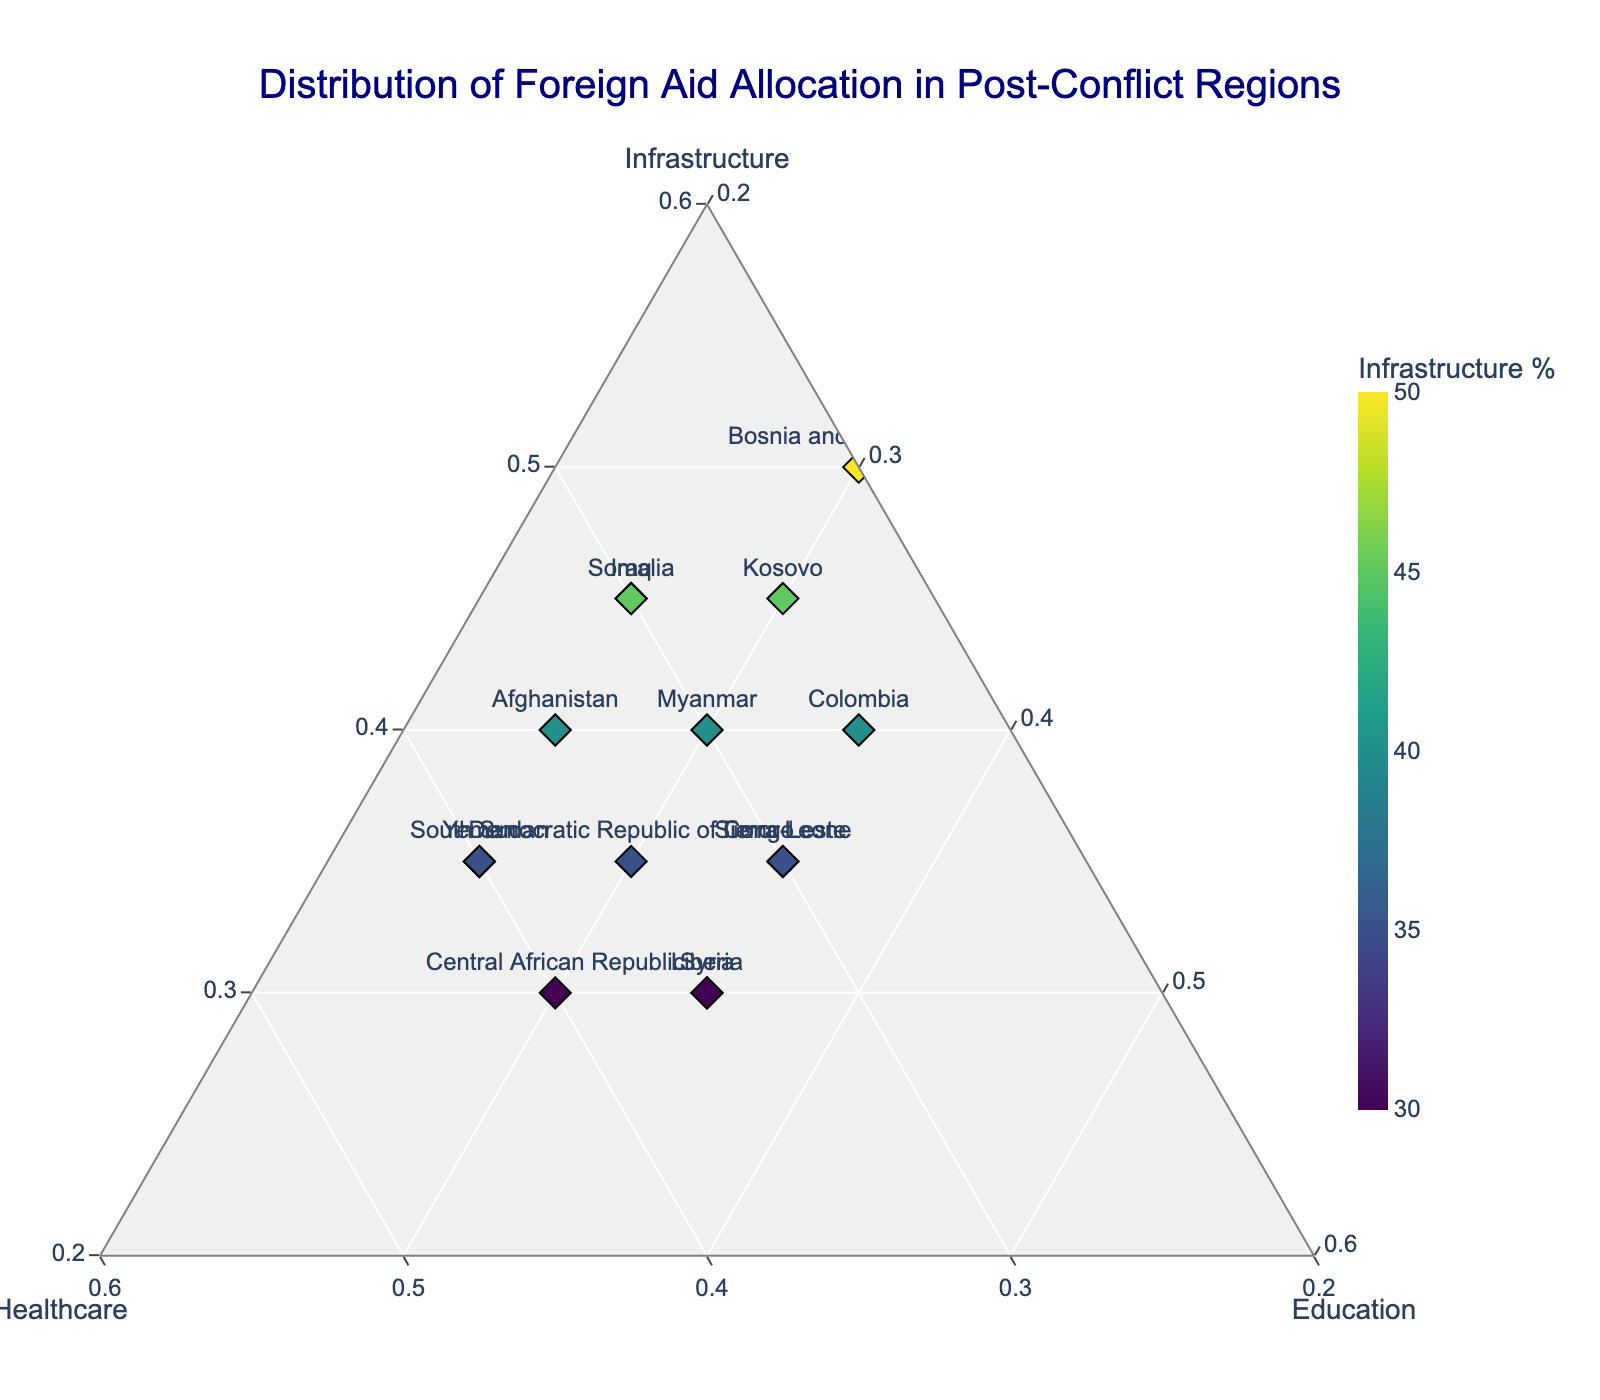what is the title of the plot? The title of the plot is usually located at the top center of the figure. In this case, the title given is "Distribution of Foreign Aid Allocation in Post-Conflict Regions".
Answer: Distribution of Foreign Aid Allocation in Post-Conflict Regions How many regions are shown in the plot? To determine the number of regions, we can count the data points or labels on the chart. Each region is marked with a label such as "Somalia", "Afghanistan", etc. Counting these, we find that there are 15 regions shown in the plot.
Answer: 15 Which region has the highest percentage of aid allocation to infrastructure? To find the region with the highest percentage in infrastructure, we look at the color intensity of the marker since it's coded by the infrastructure percentage. The color bar indicates the percentage. Bosnia and Herzegovina with 50% is the highest.
Answer: Bosnia and Herzegovina What region has equal percentages allocated to healthcare and education? By observing the ternary plot, we find that the regions with equal percentages for healthcare and education are Liberia and Sierra Leone, both have 35% each in healthcare and education.
Answer: Liberia and Sierra Leone Compare the healthcare aid between South Sudan and Yemen. Which one gets more? Checking the data points for South Sudan and Yemen on the plot, we find their positions on the healthcare axis. South Sudan has 40% and Yemen also has 40%, so they are equal in healthcare aid.
Answer: Equal What are the regions with the same distribution of 35% education? The relevant markers on the plot indicate that Syria, Timor-Leste, Liberia, and Sierra Leone all receive 35% of their aid allocation in education.
Answer: Syria, Timor-Leste, Liberia, Sierra Leone Summarize the distribution of aid in Afghanistan. To summarize, we look at the position of Afghanistan on the ternary plot. Afghanistan has 40% in infrastructure, 35% in healthcare, and 25% in education (based on the data).
Answer: 40% infrastructure, 35% healthcare, 25% education Which region has the lowest percentage of its aid allocated to healthcare? By looking at the plot, the color bar helps identify the region with the lowest healthcare allocation. Bosnia and Herzegovina has the lowest with only 20% allocated to healthcare.
Answer: Bosnia and Herzegovina Is the aid distribution in Iraq closer to that in Somalia or in Kosovo? We compare the positions of Iraq, Somalia, and Kosovo on the plot. Iraq's distribution is closest to Somalia’s distribution, which is also 45% Infrastructure, 30% Healthcare, and 25% Education similar to Iraq.
Answer: Somalia What are the minimum values set for each axis of the ternary plot? We can observe from the figure’s axis labels and configuration that the minimum values for each axis are set at 20% for Infrastructure, Healthcare, and Education.
Answer: 20% 